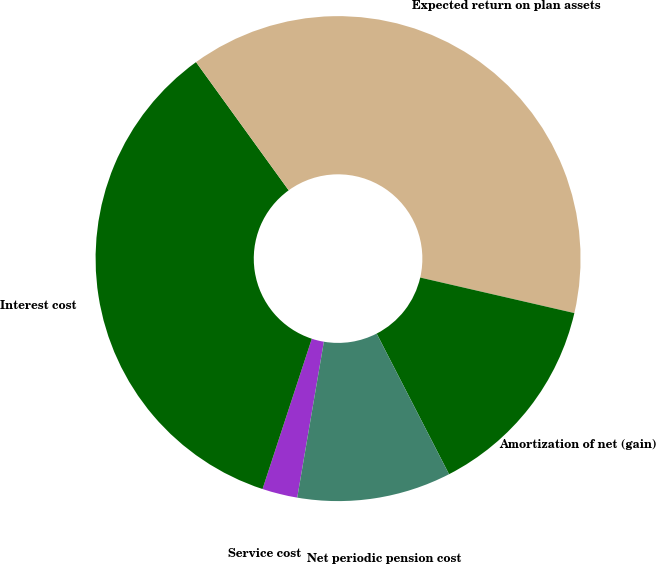Convert chart. <chart><loc_0><loc_0><loc_500><loc_500><pie_chart><fcel>Service cost<fcel>Interest cost<fcel>Expected return on plan assets<fcel>Amortization of net (gain)<fcel>Net periodic pension cost<nl><fcel>2.35%<fcel>35.0%<fcel>38.57%<fcel>13.83%<fcel>10.26%<nl></chart> 